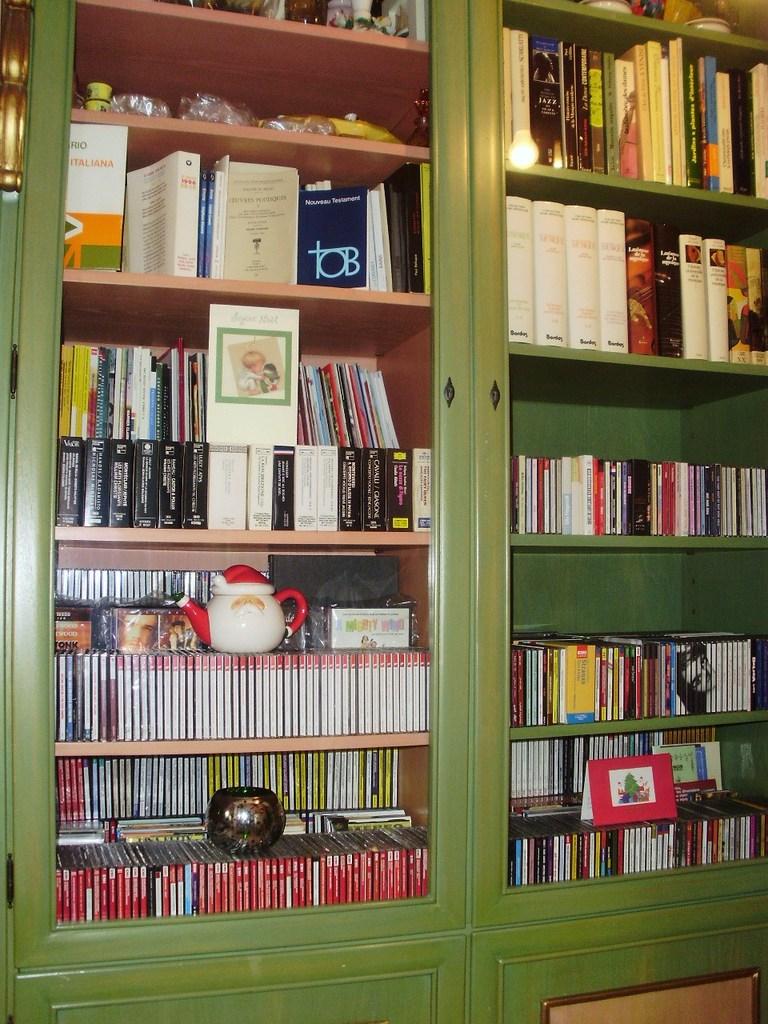What is that navy blue book?
Offer a very short reply. Tob. 